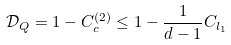Convert formula to latex. <formula><loc_0><loc_0><loc_500><loc_500>\mathcal { D } _ { Q } = 1 - C _ { c } ^ { ( 2 ) } \leq 1 - \frac { 1 } { d - 1 } C _ { l _ { 1 } }</formula> 